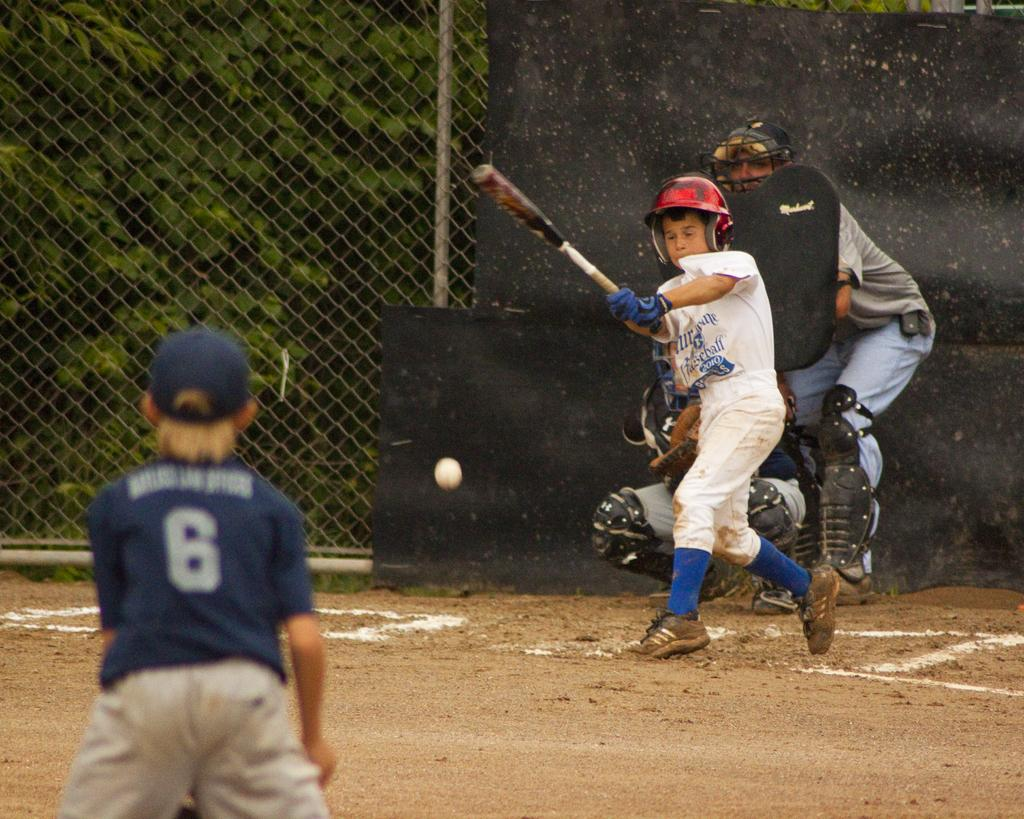What is the person in the image holding? The person is holding a bat in the image. What is the person wearing on their head? The person is wearing a helmet in the image. How many people are present in the image? There are two people in the image. What object is visible in the image that is typically used in conjunction with a bat? There is a ball in the image. What type of barrier can be seen in the image? There is net fencing in the image. What type of natural scenery is visible in the image? There are trees in the image. What type of meal is being prepared by the person in the image? There is no indication in the image that a meal is being prepared; the person is holding a bat and wearing a helmet, which suggests they are participating in a sport or game. 